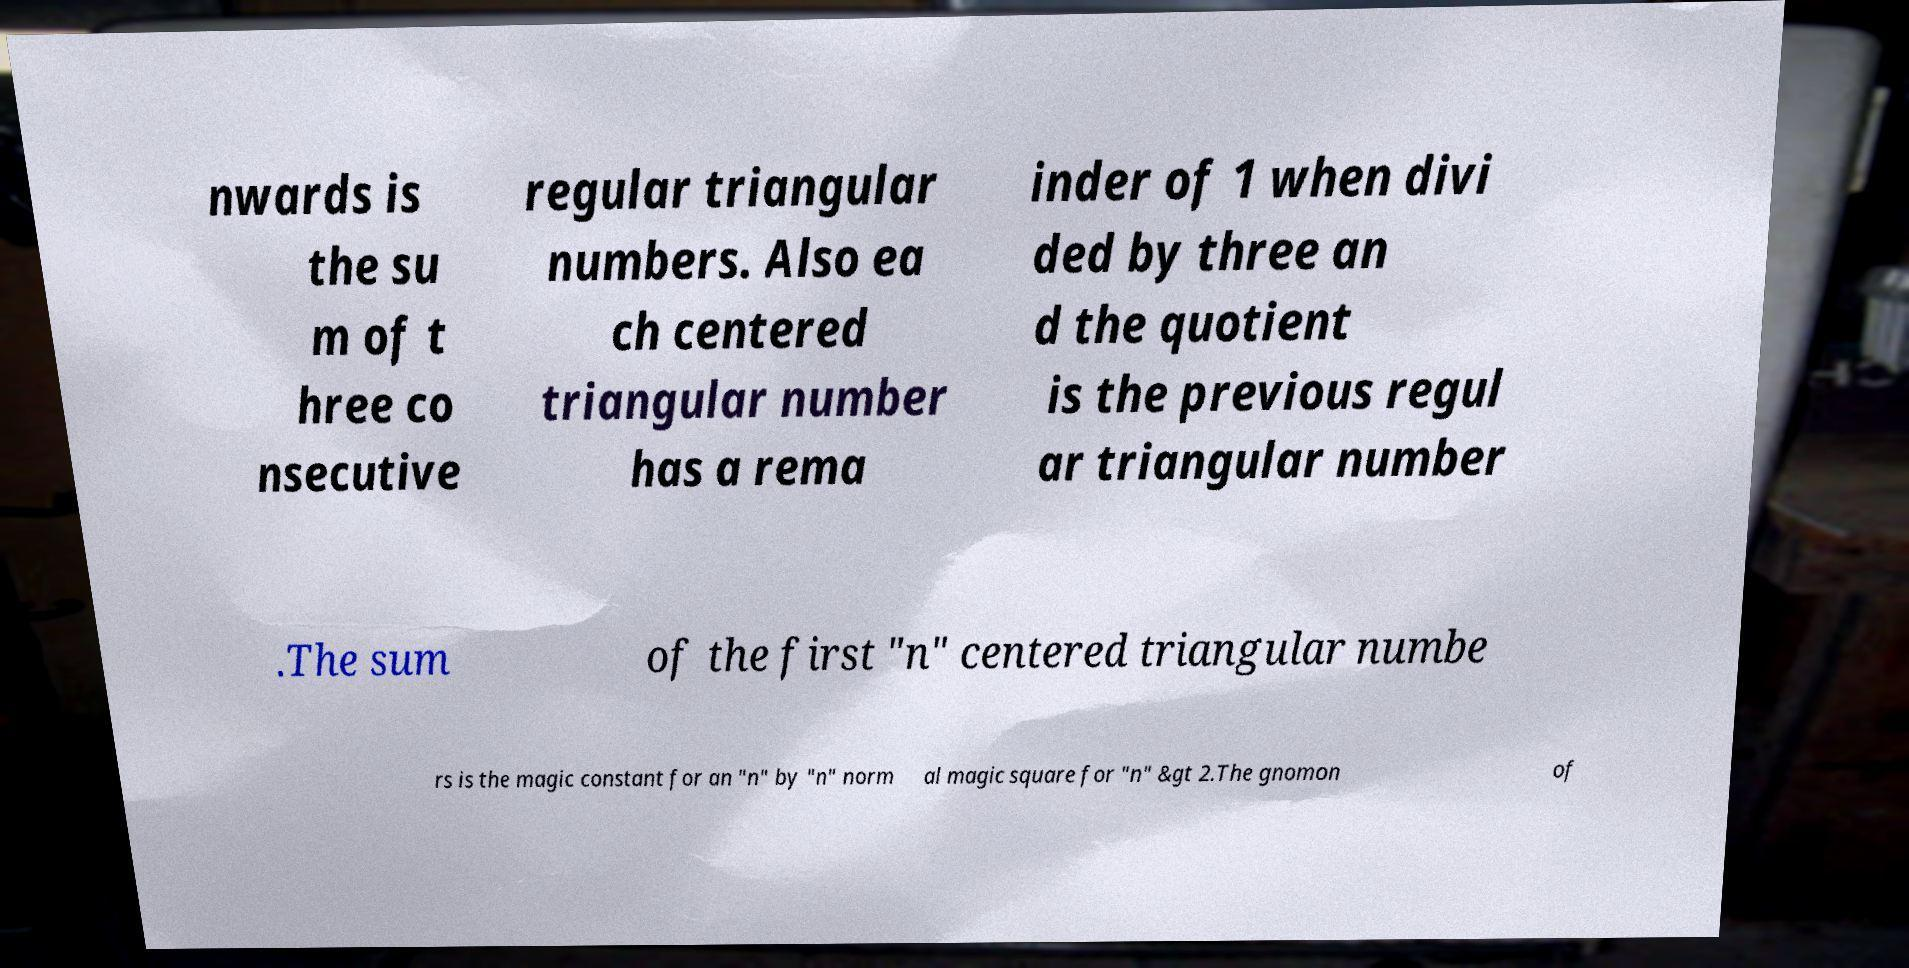Can you accurately transcribe the text from the provided image for me? nwards is the su m of t hree co nsecutive regular triangular numbers. Also ea ch centered triangular number has a rema inder of 1 when divi ded by three an d the quotient is the previous regul ar triangular number .The sum of the first "n" centered triangular numbe rs is the magic constant for an "n" by "n" norm al magic square for "n" &gt 2.The gnomon of 